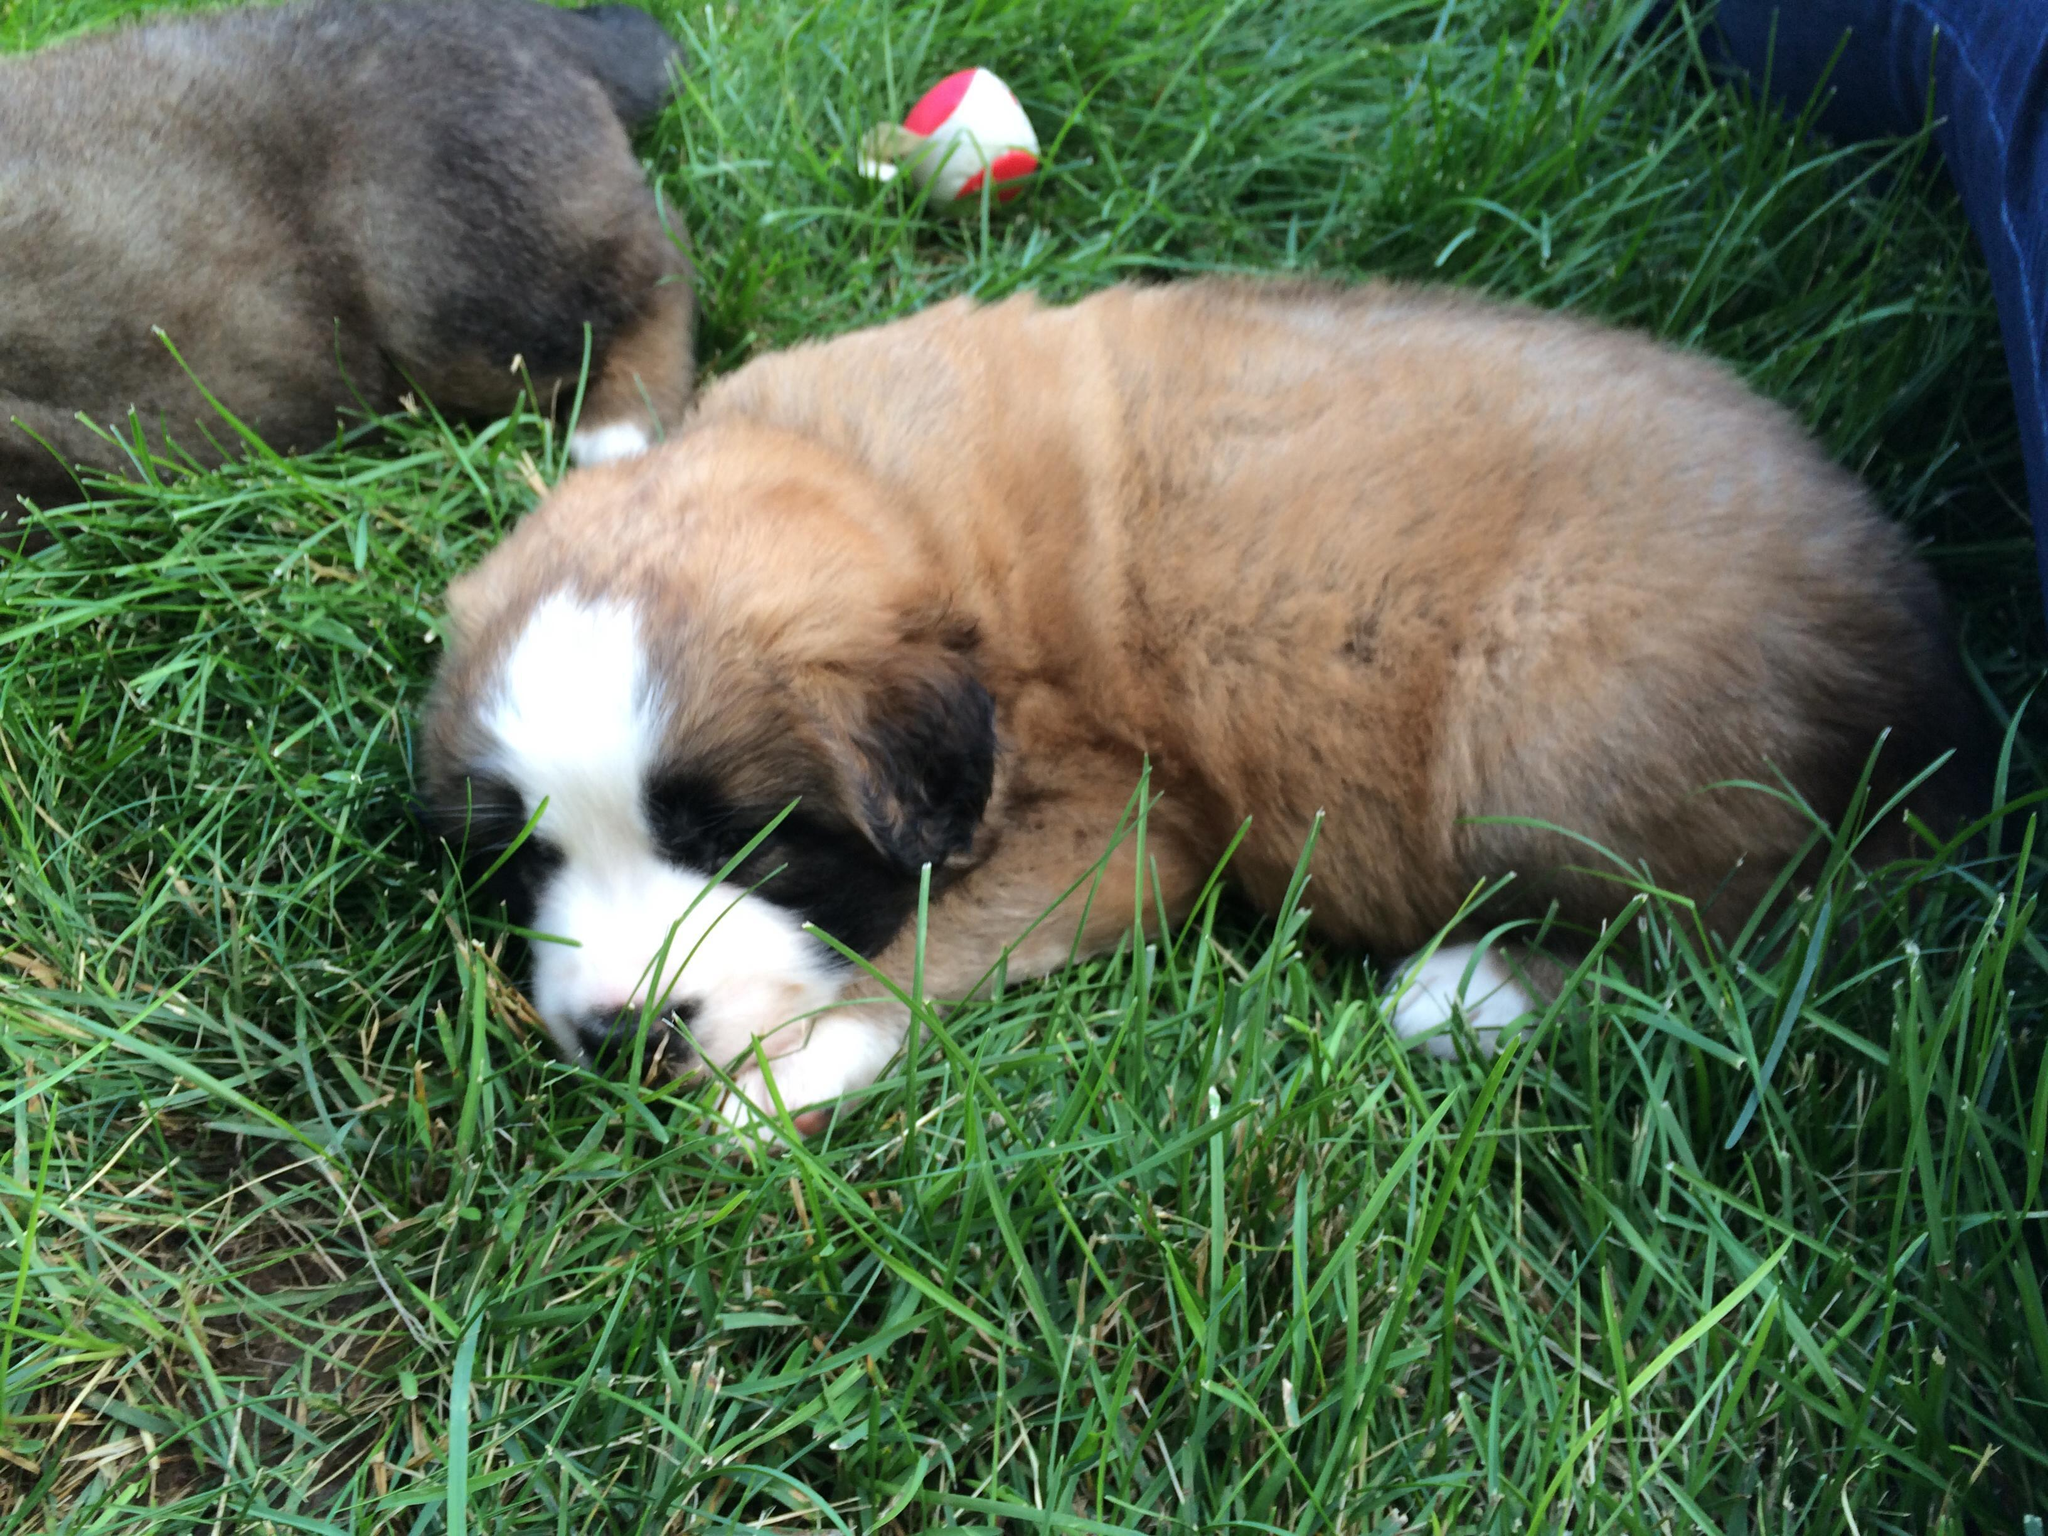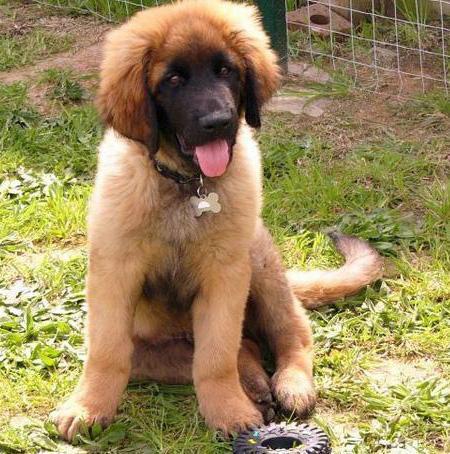The first image is the image on the left, the second image is the image on the right. Analyze the images presented: Is the assertion "There are two animals in one of the images." valid? Answer yes or no. Yes. 